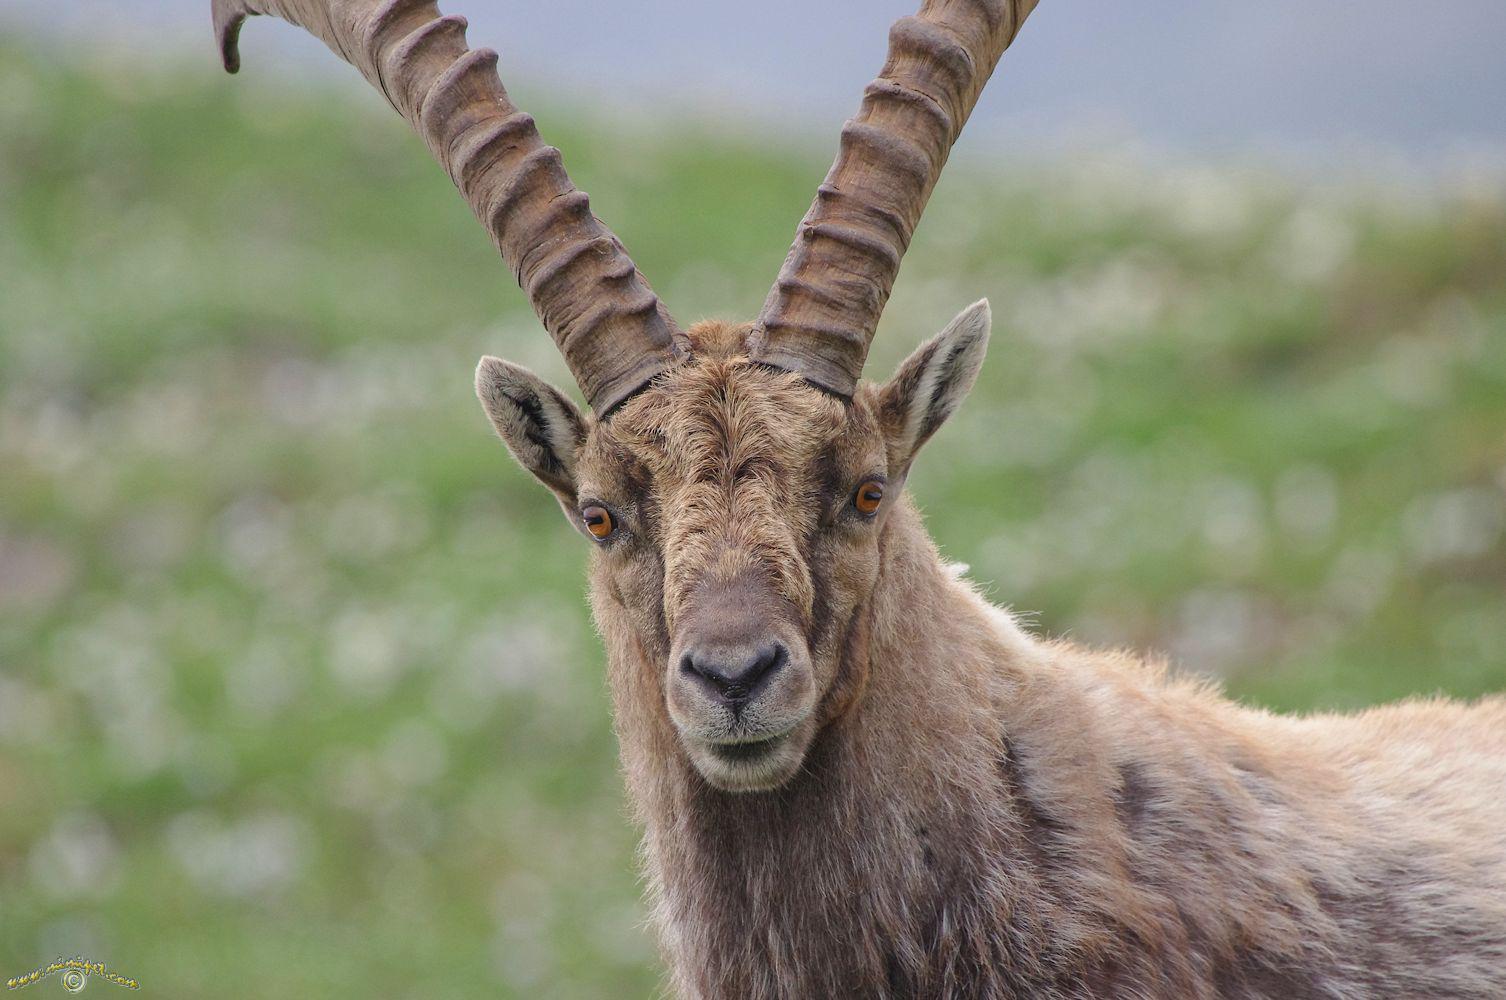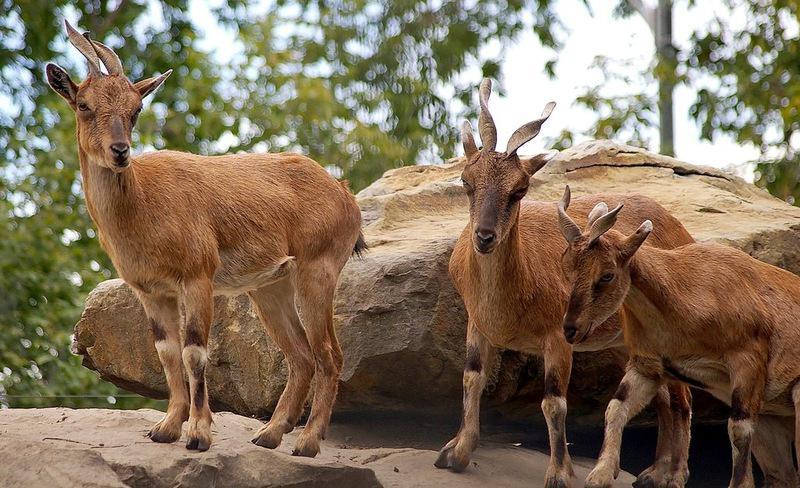The first image is the image on the left, the second image is the image on the right. Considering the images on both sides, is "The left and right image contains a total of three goat.." valid? Answer yes or no. No. The first image is the image on the left, the second image is the image on the right. Evaluate the accuracy of this statement regarding the images: "There is a total of three antelopes.". Is it true? Answer yes or no. No. 